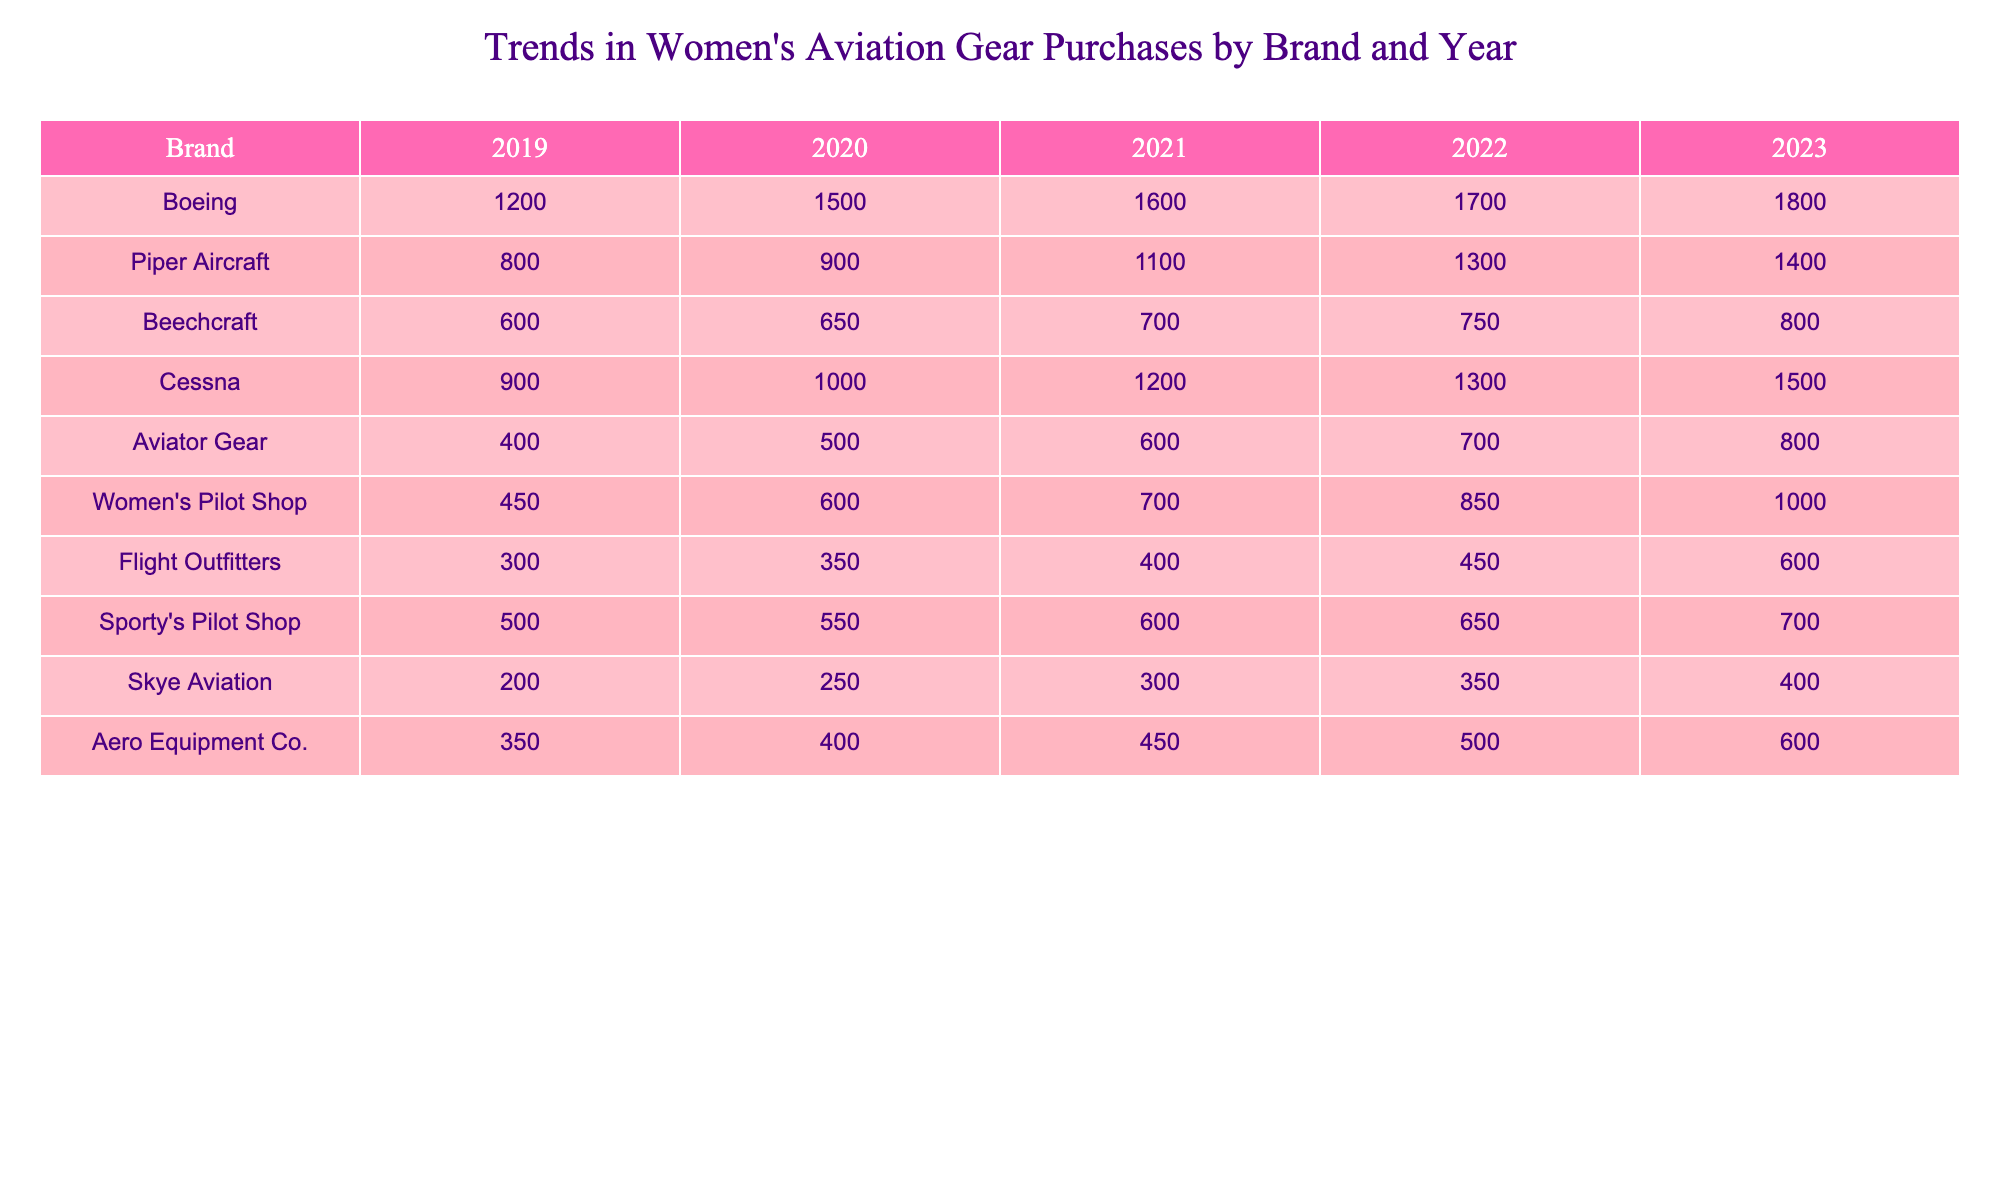What brand had the highest purchases in 2023? Looking at the values for each brand in the year 2023, Boeing has the highest number of purchases with 1800.
Answer: Boeing Which brand saw a consistent increase in purchases every year from 2019 to 2023? By examining the yearly trends for each brand, I notice that Boeing, Cessna, and Women's Pilot Shop all show a steady yearly increase without any decline.
Answer: Boeing, Cessna, Women's Pilot Shop What is the total number of purchases for Piper Aircraft over the five years? To find the total for Piper Aircraft, we add the purchases from each year: 800 + 900 + 1100 + 1300 + 1400 = 4500.
Answer: 4500 Did Skye Aviation's purchases exceed 300 in any year? Checking the yearly figures for Skye Aviation, the values were 200, 250, 300, 350, and 400. They did exceed 300 in 2022 and 2023.
Answer: Yes What was the percentage increase in the purchases of Women's Pilot Shop from 2020 to 2023? First, we determine the purchases for Women's Pilot Shop in 2020 and 2023, which are 600 and 1000, respectively. The increase is 1000 - 600 = 400. To find the percentage, we divide 400 by 600, then multiply by 100, resulting in (400/600) * 100 = 66.67%.
Answer: 66.67% Which brand had the lowest purchases in 2022? By looking at the 2022 data for all brands, I find that Flight Outfitters had the lowest purchases with 450.
Answer: Flight Outfitters What was the average number of purchases made for Beechcraft between 2019 and 2023? To calculate the average, add up the yearly purchases for Beechcraft: 600 + 650 + 700 + 750 + 800 = 3550, then divide by the number of years, which is 5. So, 3550 / 5 = 710.
Answer: 710 Did any brand's purchases in 2021 surpass 1800? Looking at the 2021 purchases, only Boeing reached 1600, and no brand exceeded 1800.
Answer: No What was the difference in purchases between Aero Equipment Co. in 2019 and in 2023? The purchases for Aero Equipment Co. in 2019 were 350, and in 2023 they were 600. The difference is 600 - 350 = 250.
Answer: 250 